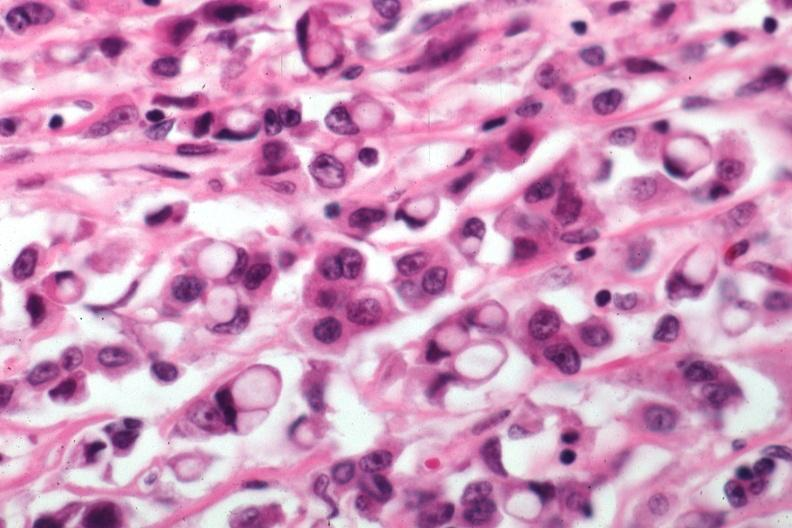s infant body present?
Answer the question using a single word or phrase. No 